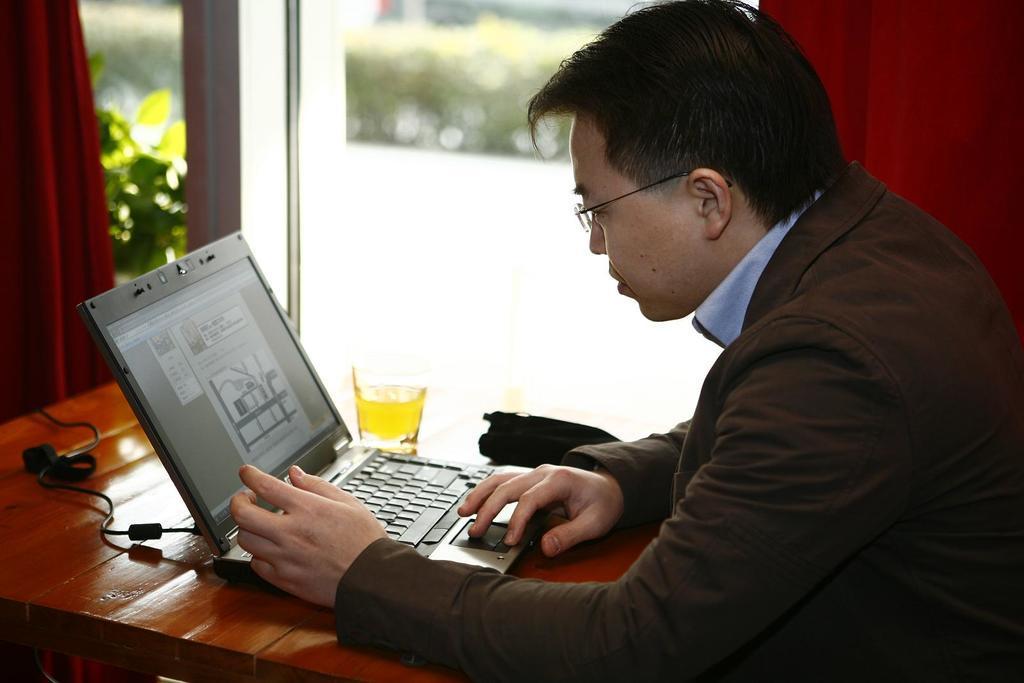How would you summarize this image in a sentence or two? In this image in the front there is a person working on a laptop which is on the table in front of him, there is a glass on the table and there is an object which is black in colour. In the background there are curtains which are red in colour and there is a window and behind the window there are plants and on the table there is a wire. 